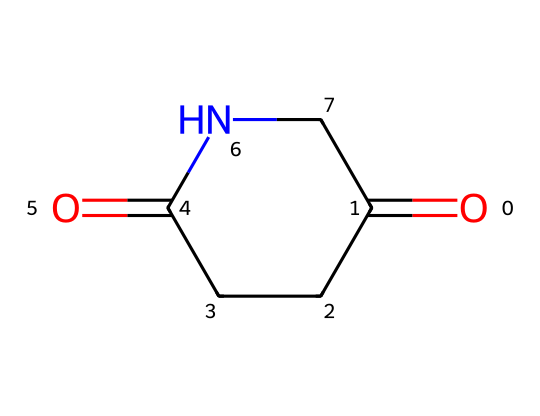What is the name of the chemical represented by this SMILES? The SMILES notation indicates a chemical structure characterized by a five-membered ring with a carbonyl and a nitrogen atom. This structure corresponds to glutarimide.
Answer: glutarimide How many carbon atoms are present in glutarimide? By analyzing the structure depicted by the SMILES, there are four carbon atoms in the cyclic structure.
Answer: 4 What type of functional groups are present in this chemical? The structure shows a carbonyl group (C=O) and an amide functional group (C=O bonded to nitrogen), which are characteristic of imides.
Answer: carbonyl and amide What kind of bond connects the nitrogen atom to the carbon in glutarimide? The nitrogen atom is connected to a carbon atom via a single covalent bond, as seen in the structure where the nitrogen (N) links to the adjacent carbon (C) in the ring.
Answer: single bond What is the molecular formula of glutarimide? Count the atoms present in the chemical structure from the SMILES: 4 carbons (C), 5 hydrogens (H), 1 nitrogen (N), and 2 oxygens (O), leading to the formula C4H5N1O2.
Answer: C4H5NO2 How does glutarimide differ from simple amides? Glutarimide includes a cyclic structure with a nitrogen atom in a ring, while simple amides do not form such a ring and consist of linear chains of carbon and nitrogen.
Answer: cyclic structure What is the unique feature of imides compared to similar compounds? Imides are characterized by the presence of cyclic structures with both carbonyl and nitrogen atoms, distinguishing them from other compounds like amides and lactams which do not have this specific configuration.
Answer: cyclic structures with nitrogen 